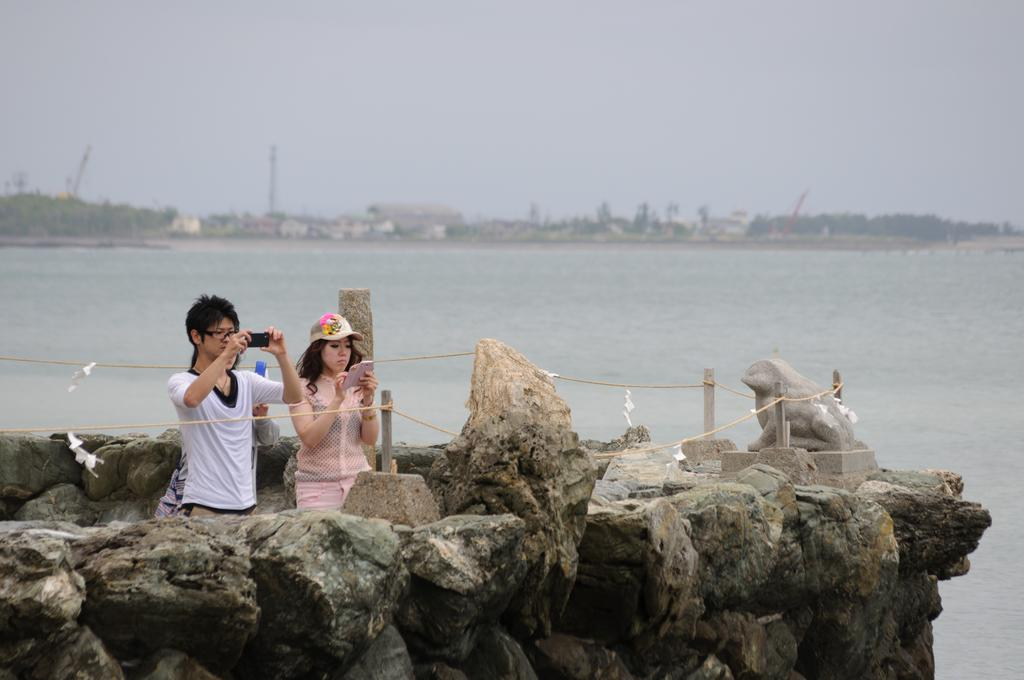What are the people in the image holding? The people in the image are holding mobiles. What type of natural features can be seen in the image? There are rocks and trees visible in the image. What is the main man-made object in the image? There is a statue in the image. What can be seen in the background of the image? There are trees and water visible in the background of the image. What type of string is being used to hold the rocks together in the image? There is no string present in the image; the rocks are not held together. Can you tell me how many moms are visible in the image? The term "mom" is not mentioned in the facts, and therefore it cannot be determined if any moms are visible in the image. 